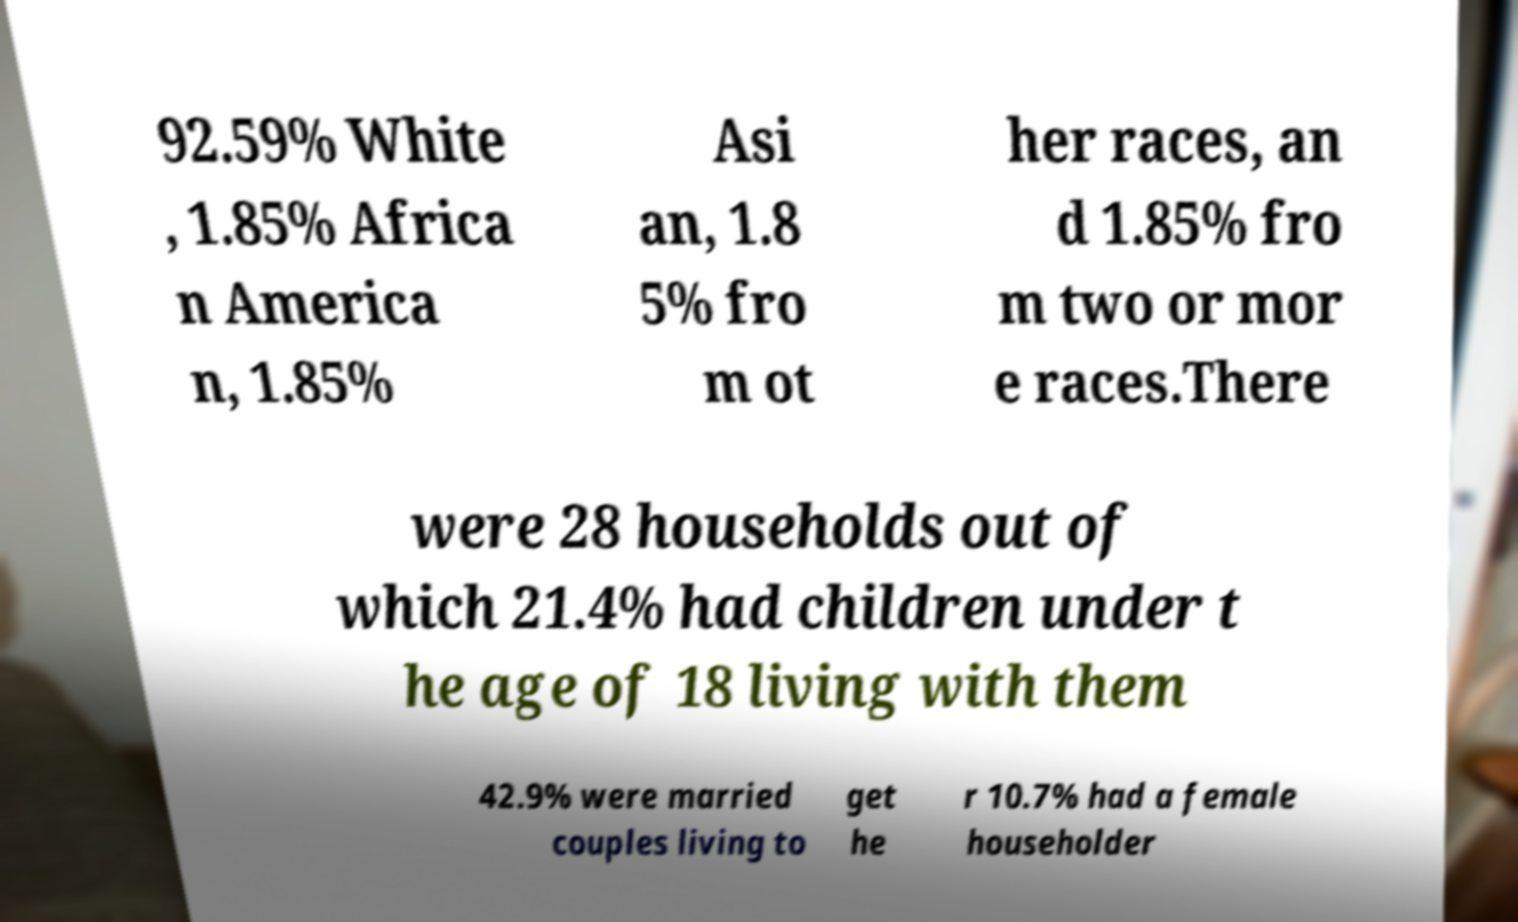Please read and relay the text visible in this image. What does it say? 92.59% White , 1.85% Africa n America n, 1.85% Asi an, 1.8 5% fro m ot her races, an d 1.85% fro m two or mor e races.There were 28 households out of which 21.4% had children under t he age of 18 living with them 42.9% were married couples living to get he r 10.7% had a female householder 